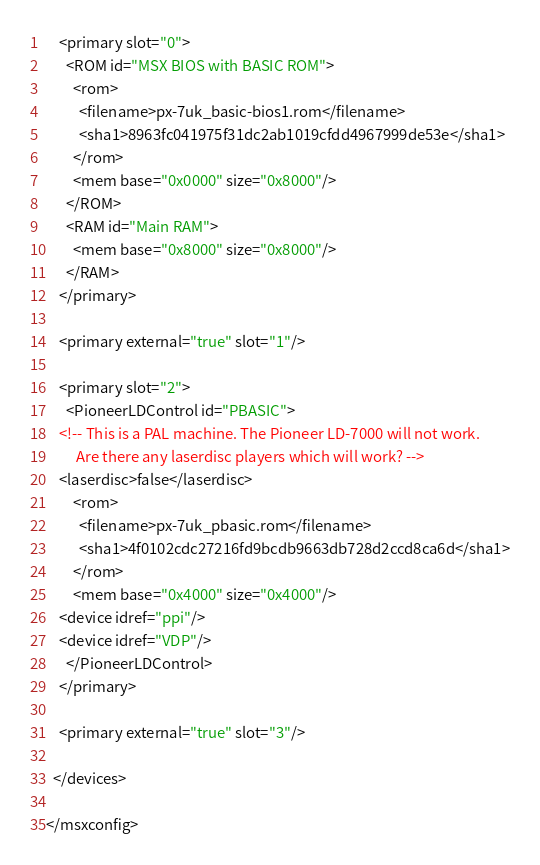Convert code to text. <code><loc_0><loc_0><loc_500><loc_500><_XML_>    <primary slot="0">
      <ROM id="MSX BIOS with BASIC ROM">
        <rom>
          <filename>px-7uk_basic-bios1.rom</filename>
          <sha1>8963fc041975f31dc2ab1019cfdd4967999de53e</sha1>
        </rom>
        <mem base="0x0000" size="0x8000"/>
      </ROM>
      <RAM id="Main RAM">
        <mem base="0x8000" size="0x8000"/>
      </RAM>
    </primary>

    <primary external="true" slot="1"/>

    <primary slot="2">
      <PioneerLDControl id="PBASIC">
	<!-- This is a PAL machine. The Pioneer LD-7000 will not work.
	     Are there any laserdisc players which will work? -->
	<laserdisc>false</laserdisc>
        <rom>
          <filename>px-7uk_pbasic.rom</filename>
          <sha1>4f0102cdc27216fd9bcdb9663db728d2ccd8ca6d</sha1>
        </rom>
        <mem base="0x4000" size="0x4000"/>
	<device idref="ppi"/>
	<device idref="VDP"/>
      </PioneerLDControl>
    </primary>

    <primary external="true" slot="3"/>

  </devices>

</msxconfig>
</code> 